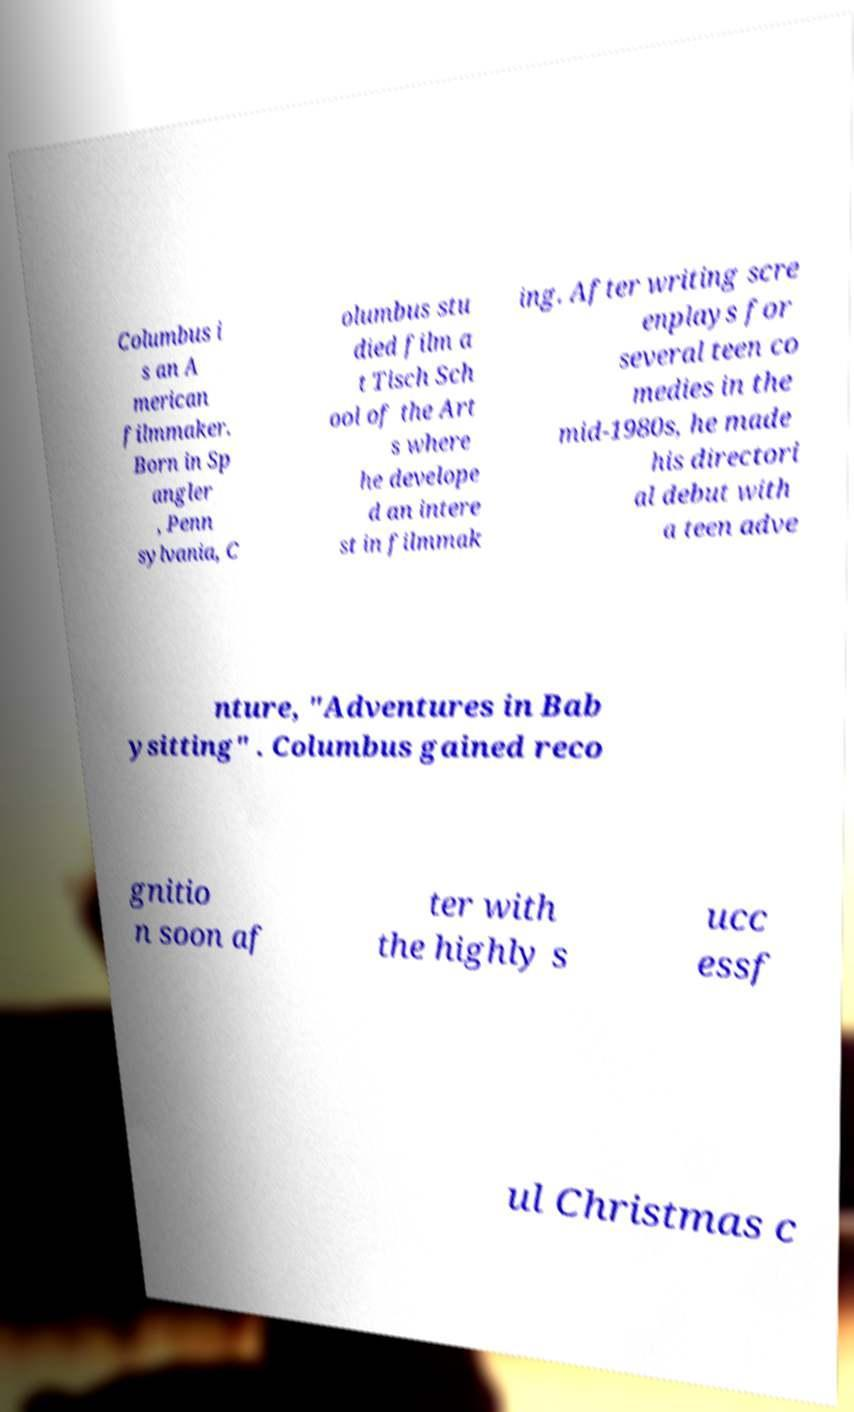Can you accurately transcribe the text from the provided image for me? Columbus i s an A merican filmmaker. Born in Sp angler , Penn sylvania, C olumbus stu died film a t Tisch Sch ool of the Art s where he develope d an intere st in filmmak ing. After writing scre enplays for several teen co medies in the mid-1980s, he made his directori al debut with a teen adve nture, "Adventures in Bab ysitting" . Columbus gained reco gnitio n soon af ter with the highly s ucc essf ul Christmas c 